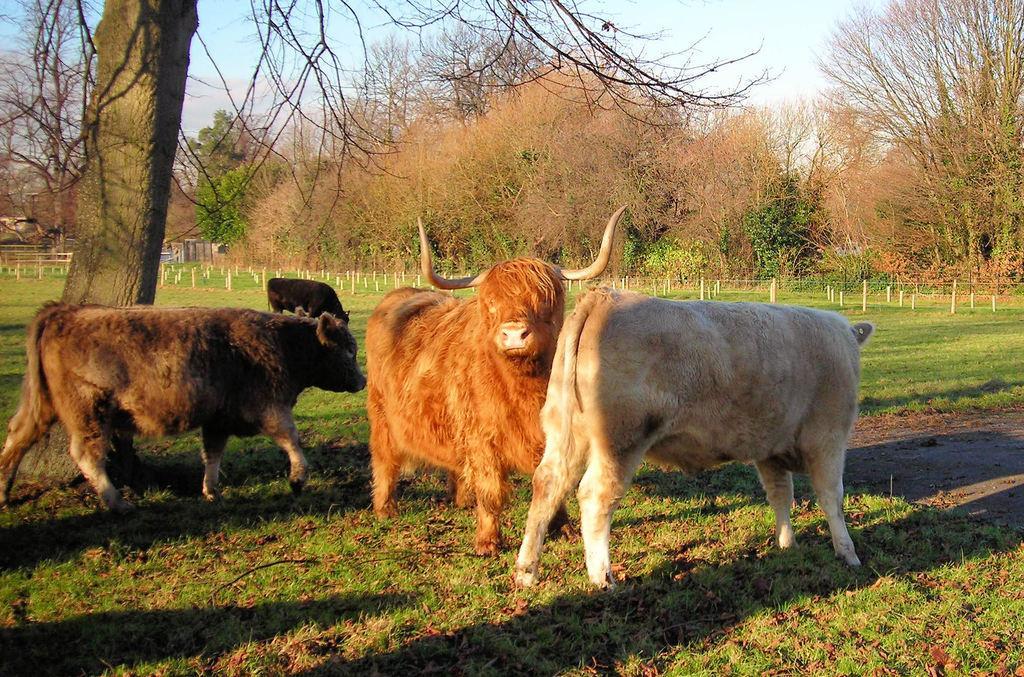In one or two sentences, can you explain what this image depicts? In this picture I can see four animals standing, there is grass, poles, trees, and in the background there is sky. 